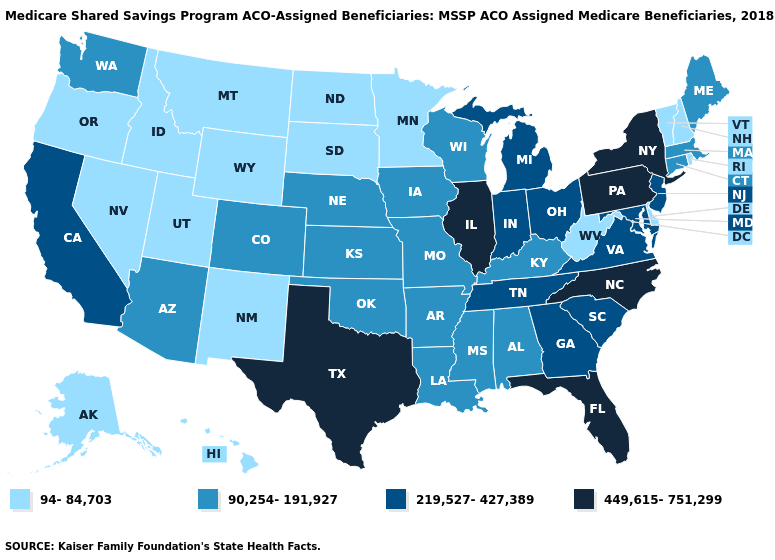Among the states that border Florida , does Georgia have the lowest value?
Be succinct. No. Does the first symbol in the legend represent the smallest category?
Write a very short answer. Yes. What is the value of New Mexico?
Be succinct. 94-84,703. Name the states that have a value in the range 90,254-191,927?
Be succinct. Alabama, Arizona, Arkansas, Colorado, Connecticut, Iowa, Kansas, Kentucky, Louisiana, Maine, Massachusetts, Mississippi, Missouri, Nebraska, Oklahoma, Washington, Wisconsin. What is the highest value in states that border California?
Quick response, please. 90,254-191,927. Among the states that border Louisiana , does Mississippi have the lowest value?
Answer briefly. Yes. What is the value of Arizona?
Short answer required. 90,254-191,927. Name the states that have a value in the range 219,527-427,389?
Answer briefly. California, Georgia, Indiana, Maryland, Michigan, New Jersey, Ohio, South Carolina, Tennessee, Virginia. Which states have the lowest value in the South?
Concise answer only. Delaware, West Virginia. What is the highest value in states that border West Virginia?
Short answer required. 449,615-751,299. Does the first symbol in the legend represent the smallest category?
Concise answer only. Yes. Name the states that have a value in the range 449,615-751,299?
Short answer required. Florida, Illinois, New York, North Carolina, Pennsylvania, Texas. Name the states that have a value in the range 90,254-191,927?
Answer briefly. Alabama, Arizona, Arkansas, Colorado, Connecticut, Iowa, Kansas, Kentucky, Louisiana, Maine, Massachusetts, Mississippi, Missouri, Nebraska, Oklahoma, Washington, Wisconsin. Which states have the highest value in the USA?
Keep it brief. Florida, Illinois, New York, North Carolina, Pennsylvania, Texas. What is the value of Utah?
Concise answer only. 94-84,703. 